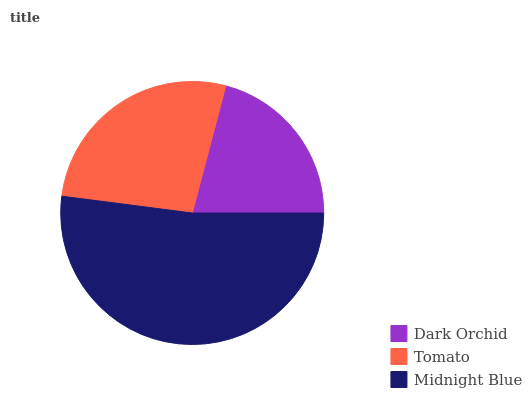Is Dark Orchid the minimum?
Answer yes or no. Yes. Is Midnight Blue the maximum?
Answer yes or no. Yes. Is Tomato the minimum?
Answer yes or no. No. Is Tomato the maximum?
Answer yes or no. No. Is Tomato greater than Dark Orchid?
Answer yes or no. Yes. Is Dark Orchid less than Tomato?
Answer yes or no. Yes. Is Dark Orchid greater than Tomato?
Answer yes or no. No. Is Tomato less than Dark Orchid?
Answer yes or no. No. Is Tomato the high median?
Answer yes or no. Yes. Is Tomato the low median?
Answer yes or no. Yes. Is Midnight Blue the high median?
Answer yes or no. No. Is Dark Orchid the low median?
Answer yes or no. No. 